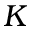<formula> <loc_0><loc_0><loc_500><loc_500>K</formula> 